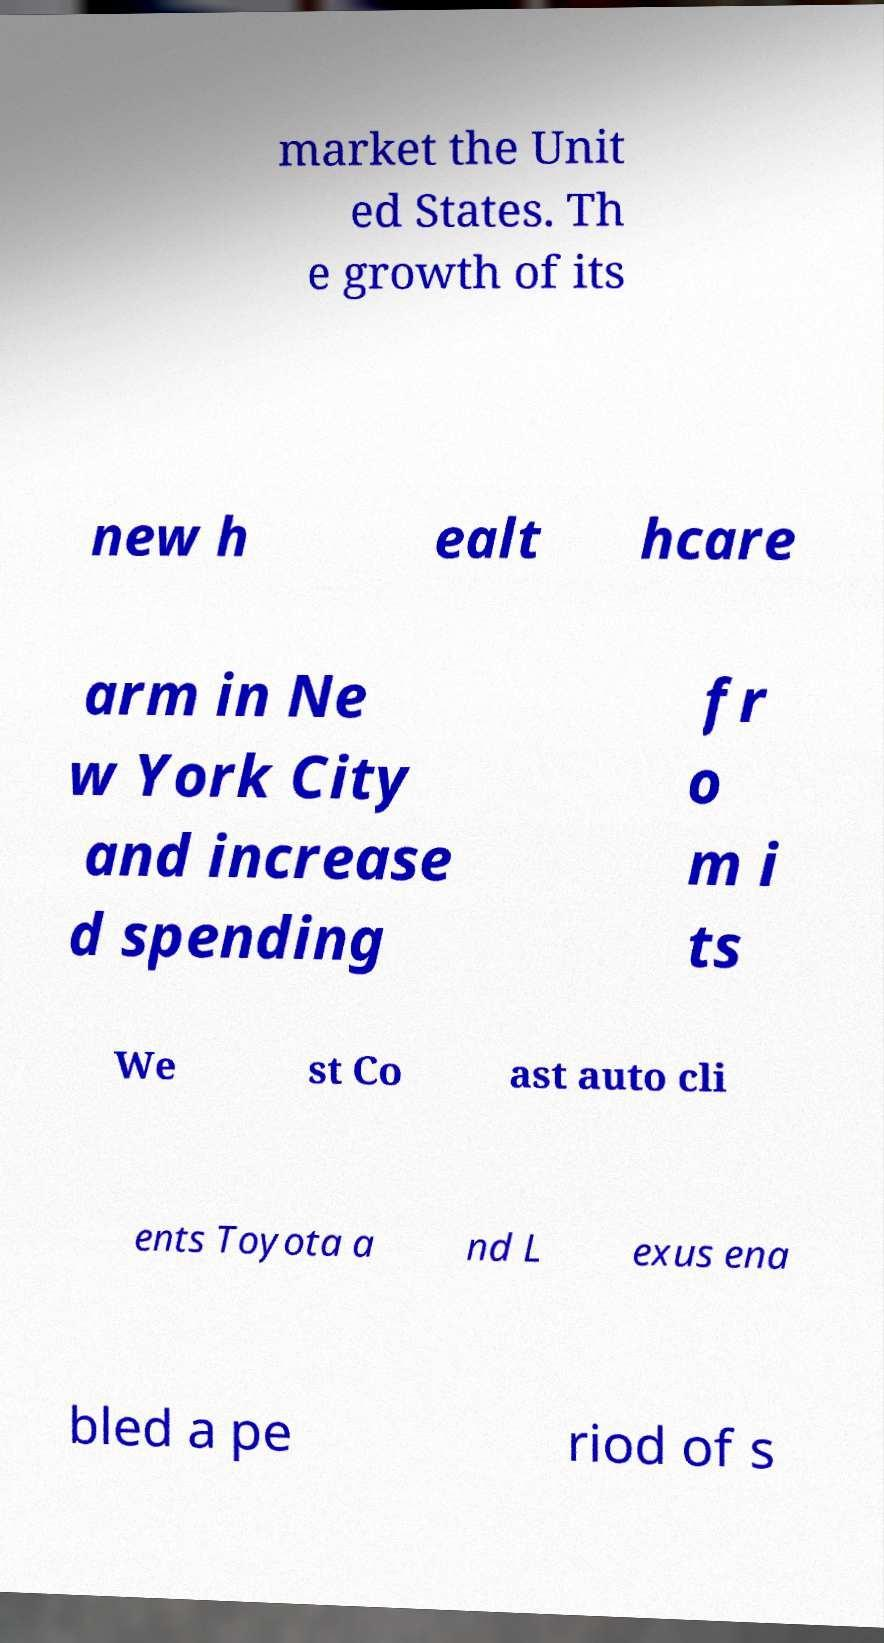Could you extract and type out the text from this image? market the Unit ed States. Th e growth of its new h ealt hcare arm in Ne w York City and increase d spending fr o m i ts We st Co ast auto cli ents Toyota a nd L exus ena bled a pe riod of s 